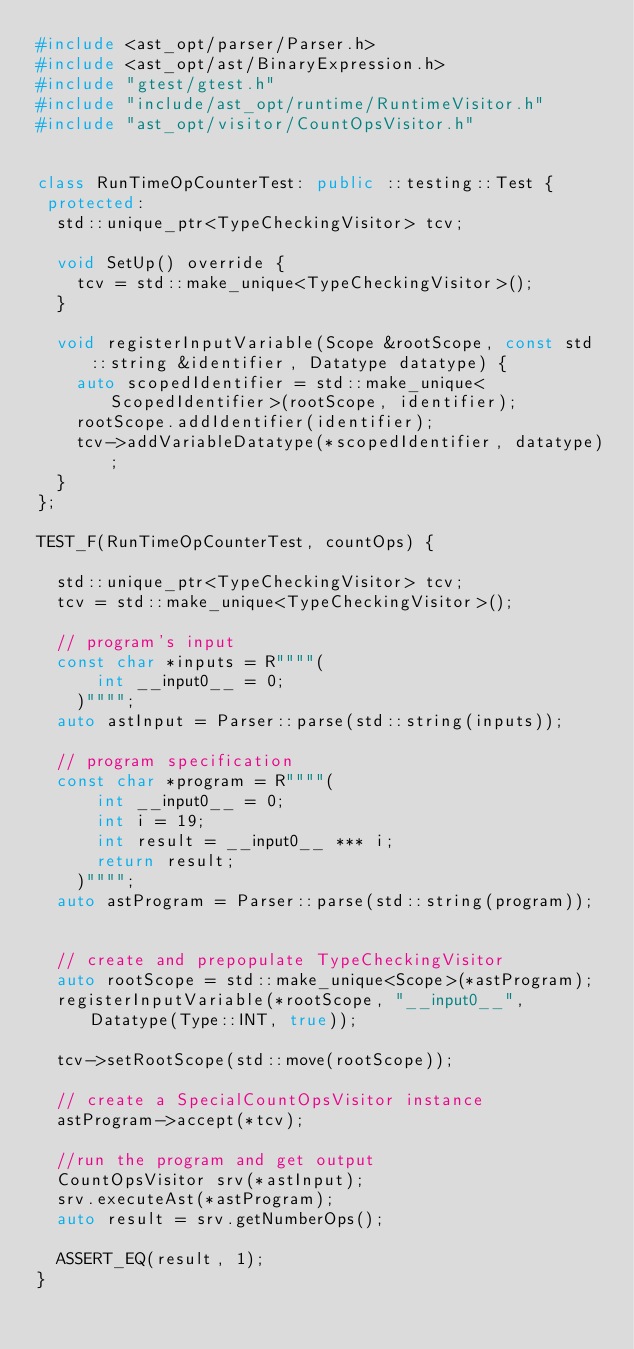Convert code to text. <code><loc_0><loc_0><loc_500><loc_500><_C++_>#include <ast_opt/parser/Parser.h>
#include <ast_opt/ast/BinaryExpression.h>
#include "gtest/gtest.h"
#include "include/ast_opt/runtime/RuntimeVisitor.h"
#include "ast_opt/visitor/CountOpsVisitor.h"


class RunTimeOpCounterTest: public ::testing::Test {
 protected:
  std::unique_ptr<TypeCheckingVisitor> tcv;

  void SetUp() override {
    tcv = std::make_unique<TypeCheckingVisitor>();
  }

  void registerInputVariable(Scope &rootScope, const std::string &identifier, Datatype datatype) {
    auto scopedIdentifier = std::make_unique<ScopedIdentifier>(rootScope, identifier);
    rootScope.addIdentifier(identifier);
    tcv->addVariableDatatype(*scopedIdentifier, datatype);
  }
};

TEST_F(RunTimeOpCounterTest, countOps) {

  std::unique_ptr<TypeCheckingVisitor> tcv;
  tcv = std::make_unique<TypeCheckingVisitor>();

  // program's input
  const char *inputs = R""""(
      int __input0__ = 0;
    )"""";
  auto astInput = Parser::parse(std::string(inputs));

  // program specification
  const char *program = R""""(
      int __input0__ = 0;
      int i = 19;
      int result = __input0__ *** i;
      return result;
    )"""";
  auto astProgram = Parser::parse(std::string(program));


  // create and prepopulate TypeCheckingVisitor
  auto rootScope = std::make_unique<Scope>(*astProgram);
  registerInputVariable(*rootScope, "__input0__", Datatype(Type::INT, true));

  tcv->setRootScope(std::move(rootScope));

  // create a SpecialCountOpsVisitor instance
  astProgram->accept(*tcv);

  //run the program and get output
  CountOpsVisitor srv(*astInput);
  srv.executeAst(*astProgram);
  auto result = srv.getNumberOps();

  ASSERT_EQ(result, 1);
}
</code> 